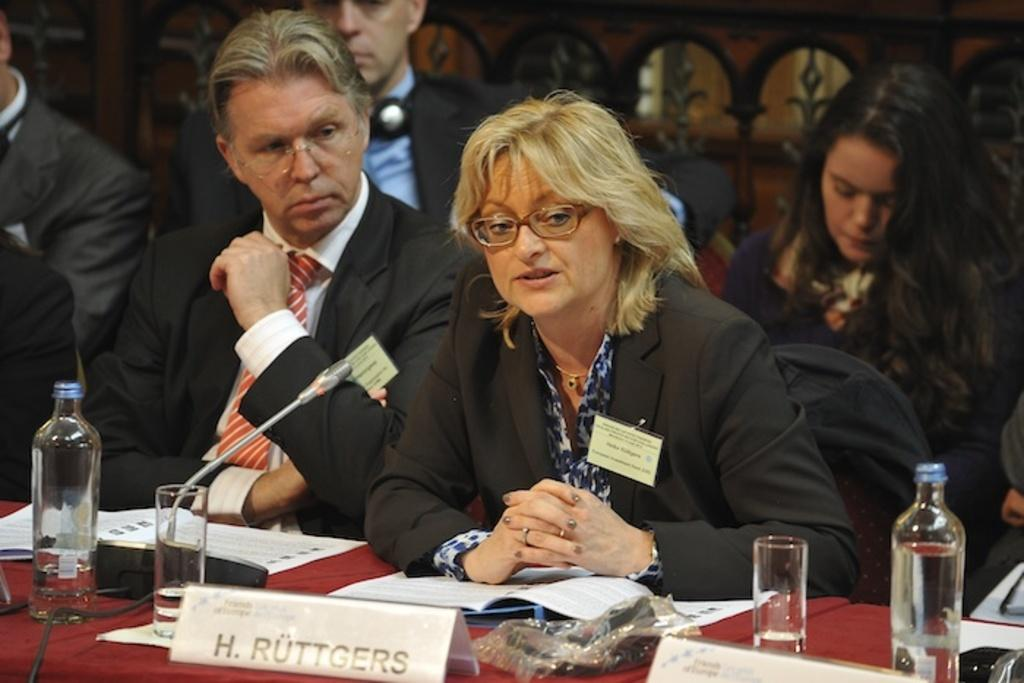How many people are in the image? There is a group of persons in the image, but the exact number cannot be determined from the provided facts. What is located behind the persons in the image? Chairs and a group of objects are visible behind the persons in the image. What is located on a surface in front of the persons in the image? There is a group of objects on a surface in front of the persons in the image. How many deer are visible in the image? There are no deer present in the image. What type of chairs are the persons sitting on in the image? The provided facts do not specify the type of chairs visible behind the persons in the image. 